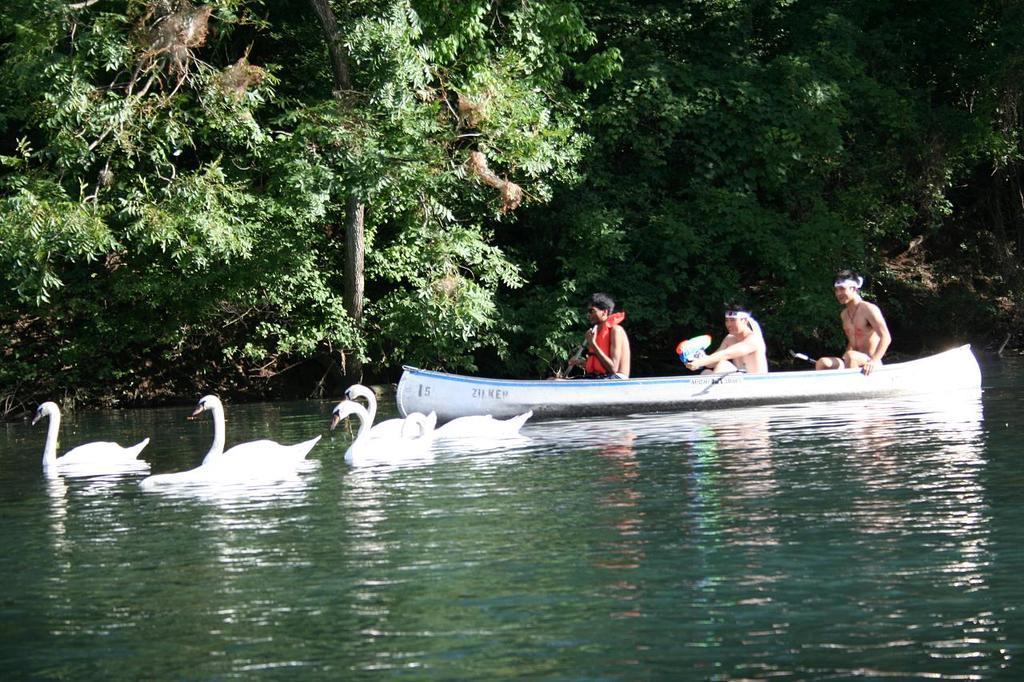Could you give a brief overview of what you see in this image? In this image there is a lake in that lake there are swans and there is a boat, in that boat there are three persons, in the background there are trees. 